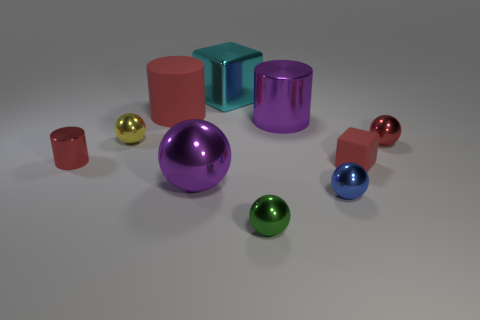How many other things are the same color as the large ball?
Offer a very short reply. 1. Is the purple object that is behind the red metallic sphere made of the same material as the cyan thing?
Offer a very short reply. Yes. Are there fewer big cylinders behind the big red cylinder than cylinders in front of the blue sphere?
Provide a short and direct response. No. What number of other objects are there of the same material as the yellow object?
Provide a succinct answer. 7. What material is the red block that is the same size as the blue object?
Your response must be concise. Rubber. Are there fewer tiny red rubber blocks that are in front of the red sphere than big red rubber blocks?
Your answer should be very brief. No. There is a matte thing that is to the right of the red cylinder that is behind the small red object left of the large red cylinder; what is its shape?
Your response must be concise. Cube. There is a cube left of the small green thing; what size is it?
Keep it short and to the point. Large. What shape is the red thing that is the same size as the cyan metallic object?
Give a very brief answer. Cylinder. What number of objects are tiny green rubber objects or shiny cylinders that are to the left of the rubber cylinder?
Make the answer very short. 1. 